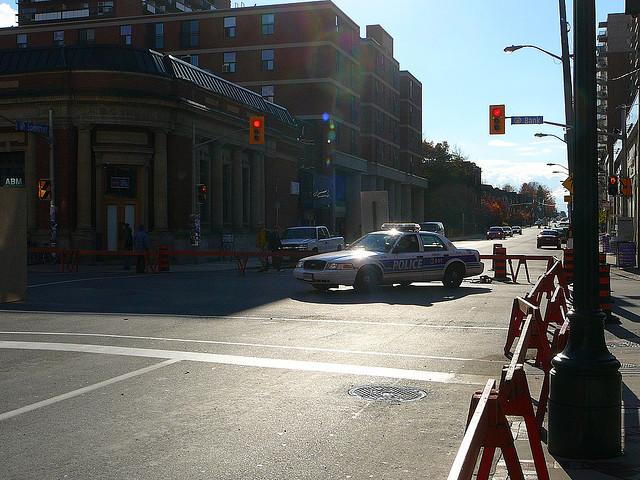What color is the stoplight?
Write a very short answer. Red. What does the lettering on the car say?
Quick response, please. Police. Are there barricades in the street?
Write a very short answer. Yes. 